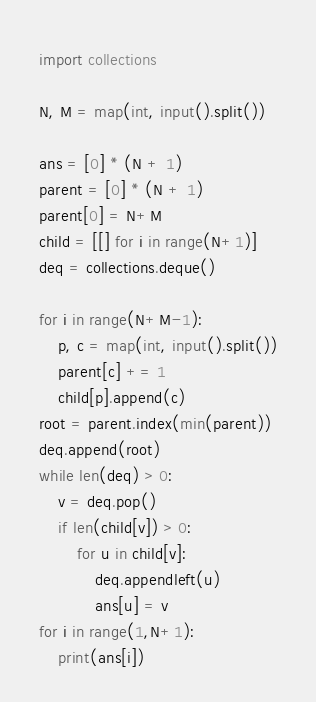Convert code to text. <code><loc_0><loc_0><loc_500><loc_500><_Python_>import collections

N, M = map(int, input().split())

ans = [0] * (N + 1)
parent = [0] * (N + 1)
parent[0] = N+M
child = [[] for i in range(N+1)]
deq = collections.deque()

for i in range(N+M-1):
    p, c = map(int, input().split())
    parent[c] += 1
    child[p].append(c)
root = parent.index(min(parent))
deq.append(root)
while len(deq) > 0:
    v = deq.pop()
    if len(child[v]) > 0:
        for u in child[v]:
            deq.appendleft(u)
            ans[u] = v
for i in range(1,N+1):
    print(ans[i])</code> 